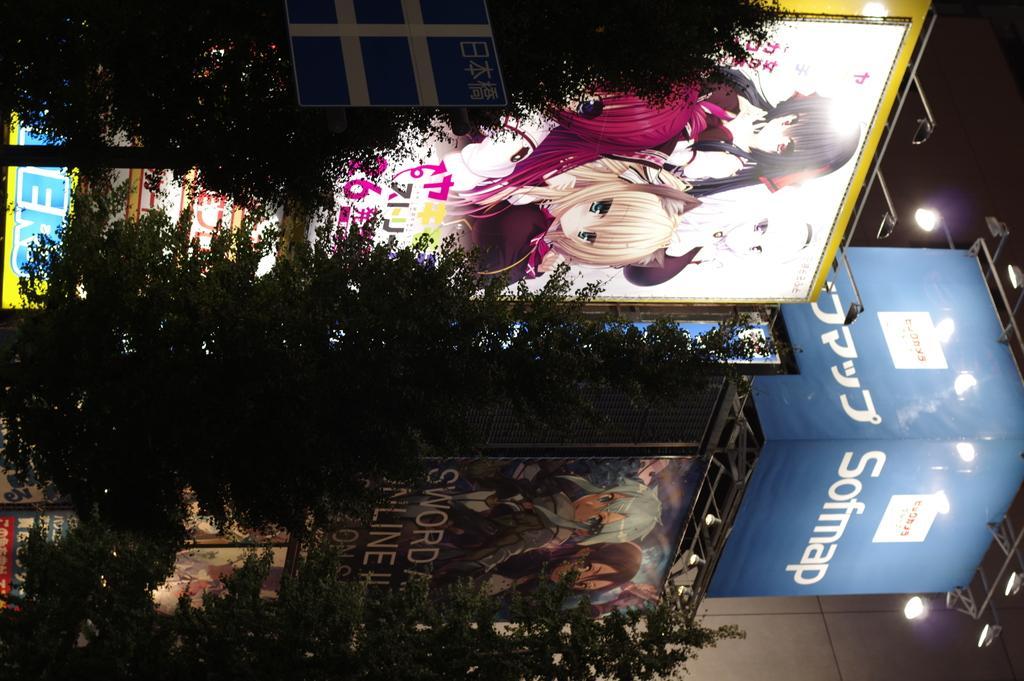Please provide a concise description of this image. This image is in right direction. On the left side there are trees and boards on which I can see the text. In the middle of the image there are two boards on which I can see few cartoon images and text. On the right side there is a black color box and few lights attached to the metal rods. 